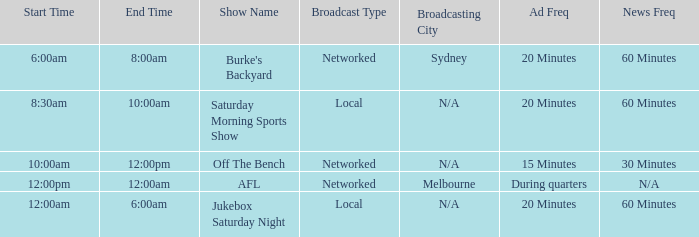What is the local/network with an Ad frequency of 15 minutes? Networked. 